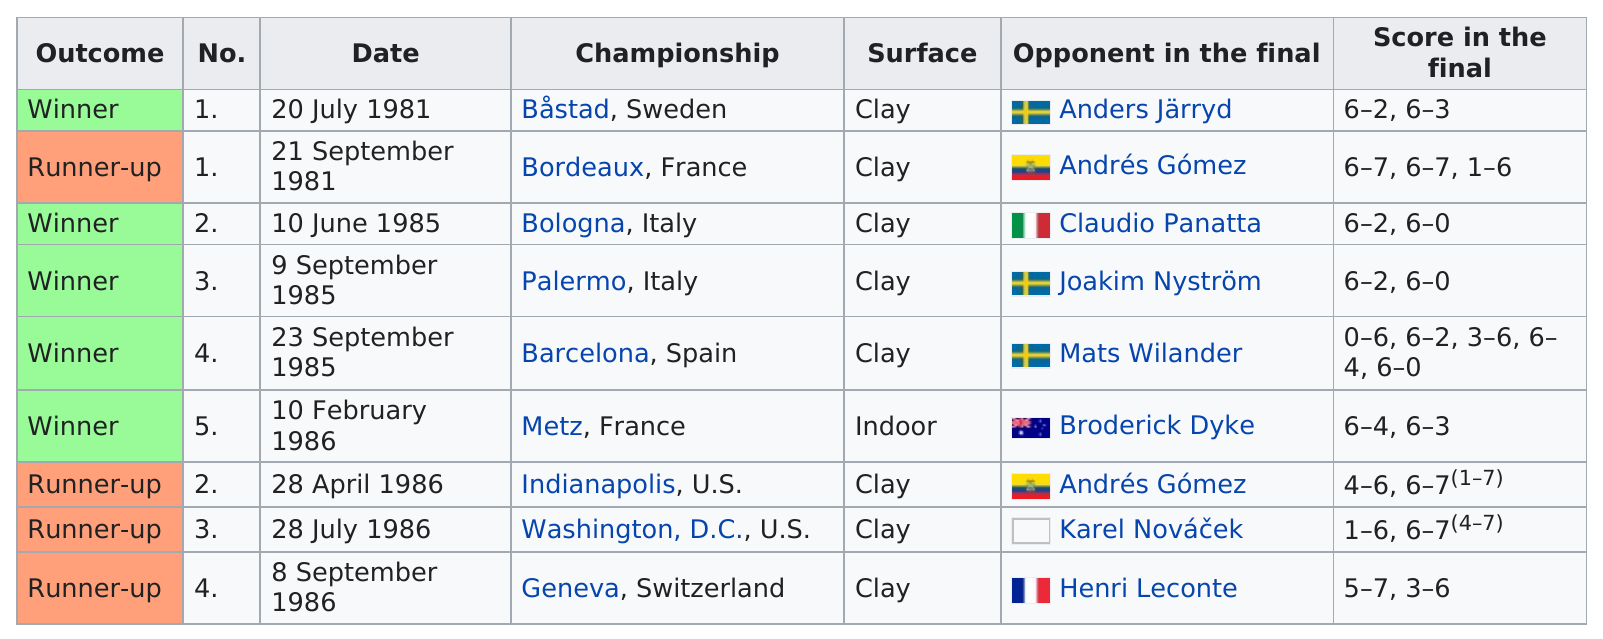Outline some significant characteristics in this image. Andrés Gómez is the only player to have been listed twice as an opponent in the finals. Henri Leconte was the opponent in the last tournament. The number of tournaments played indoors is 1. Thierry Tulasne won a total of 5 ATP Tour titles in his career. Thierry Tulasne won two consecutive titles in Italy in 1985. 